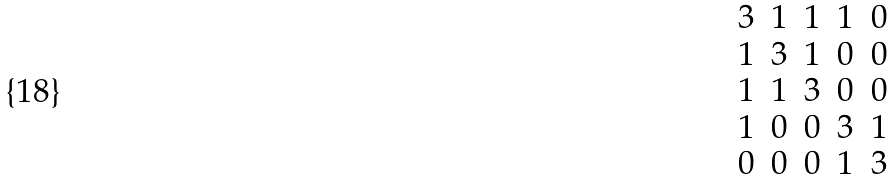Convert formula to latex. <formula><loc_0><loc_0><loc_500><loc_500>\begin{matrix} 3 & 1 & 1 & 1 & 0 \\ 1 & 3 & 1 & 0 & 0 \\ 1 & 1 & 3 & 0 & 0 \\ 1 & 0 & 0 & 3 & 1 \\ 0 & 0 & 0 & 1 & 3 \end{matrix}</formula> 